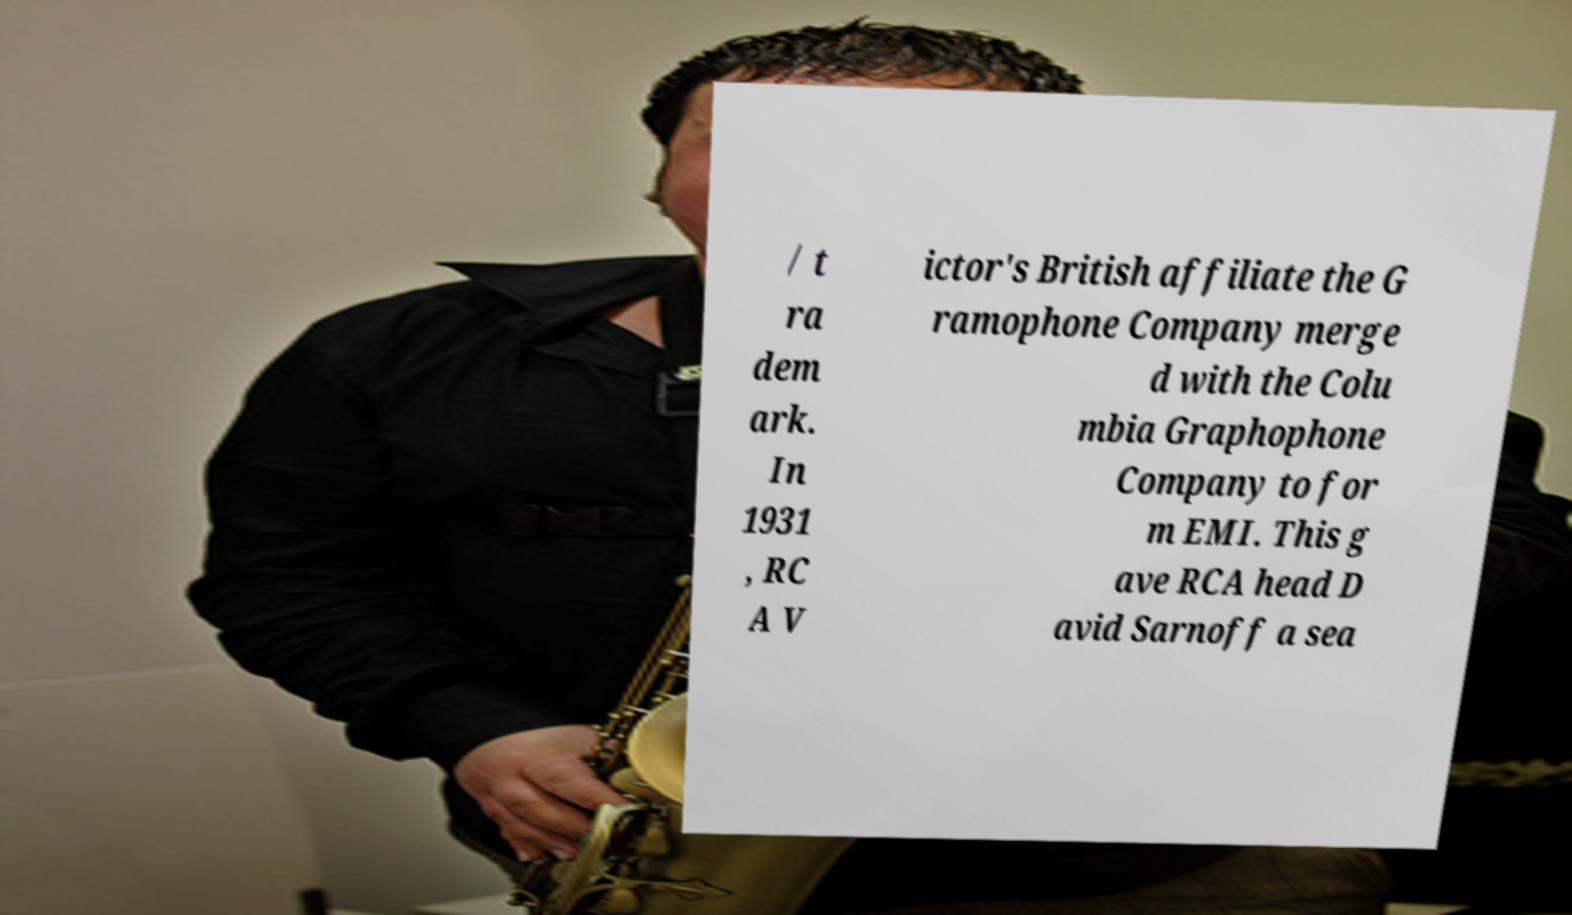Please read and relay the text visible in this image. What does it say? / t ra dem ark. In 1931 , RC A V ictor's British affiliate the G ramophone Company merge d with the Colu mbia Graphophone Company to for m EMI. This g ave RCA head D avid Sarnoff a sea 